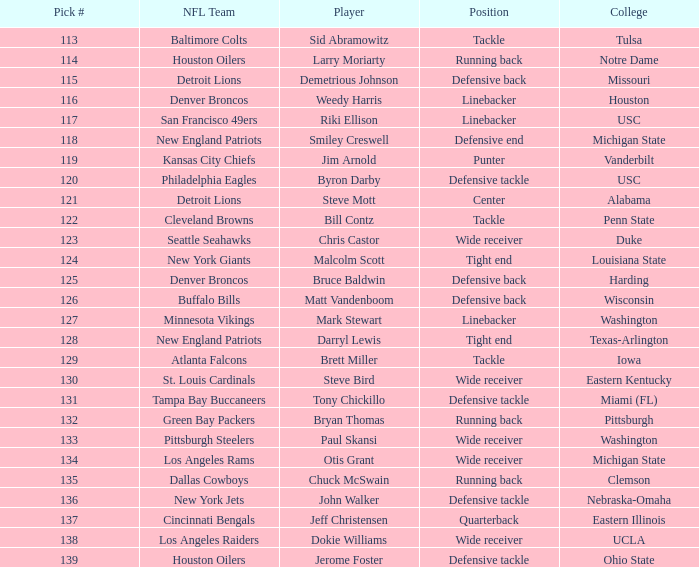How many players did the philadelphia eagles pick? 1.0. 